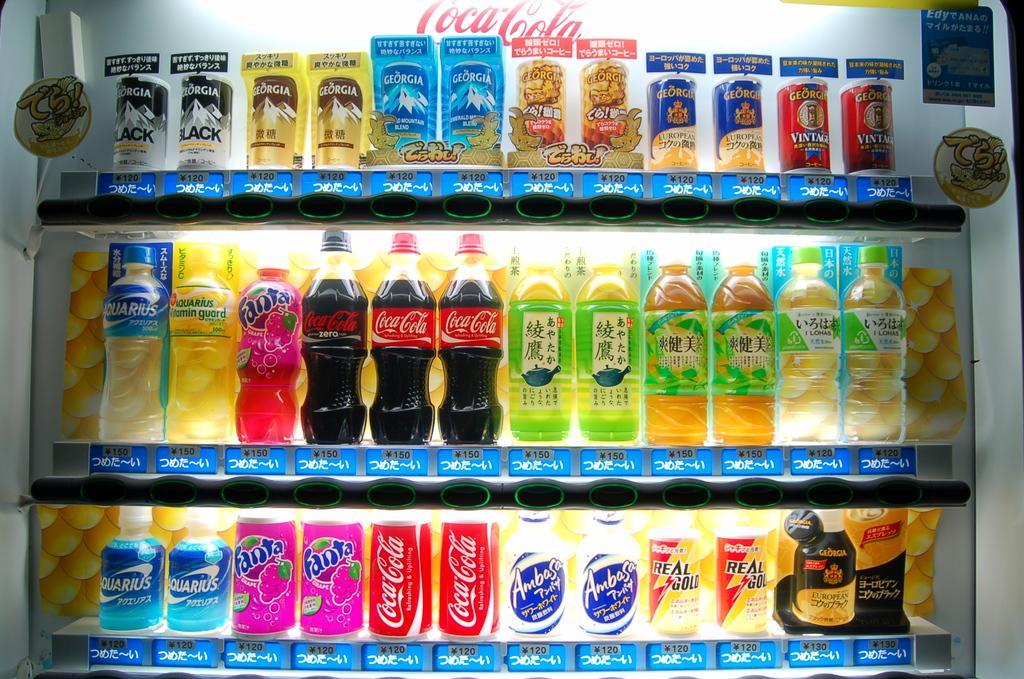Could you give a brief overview of what you see in this image? In this picture we can see few bottles and tins in the racks. 